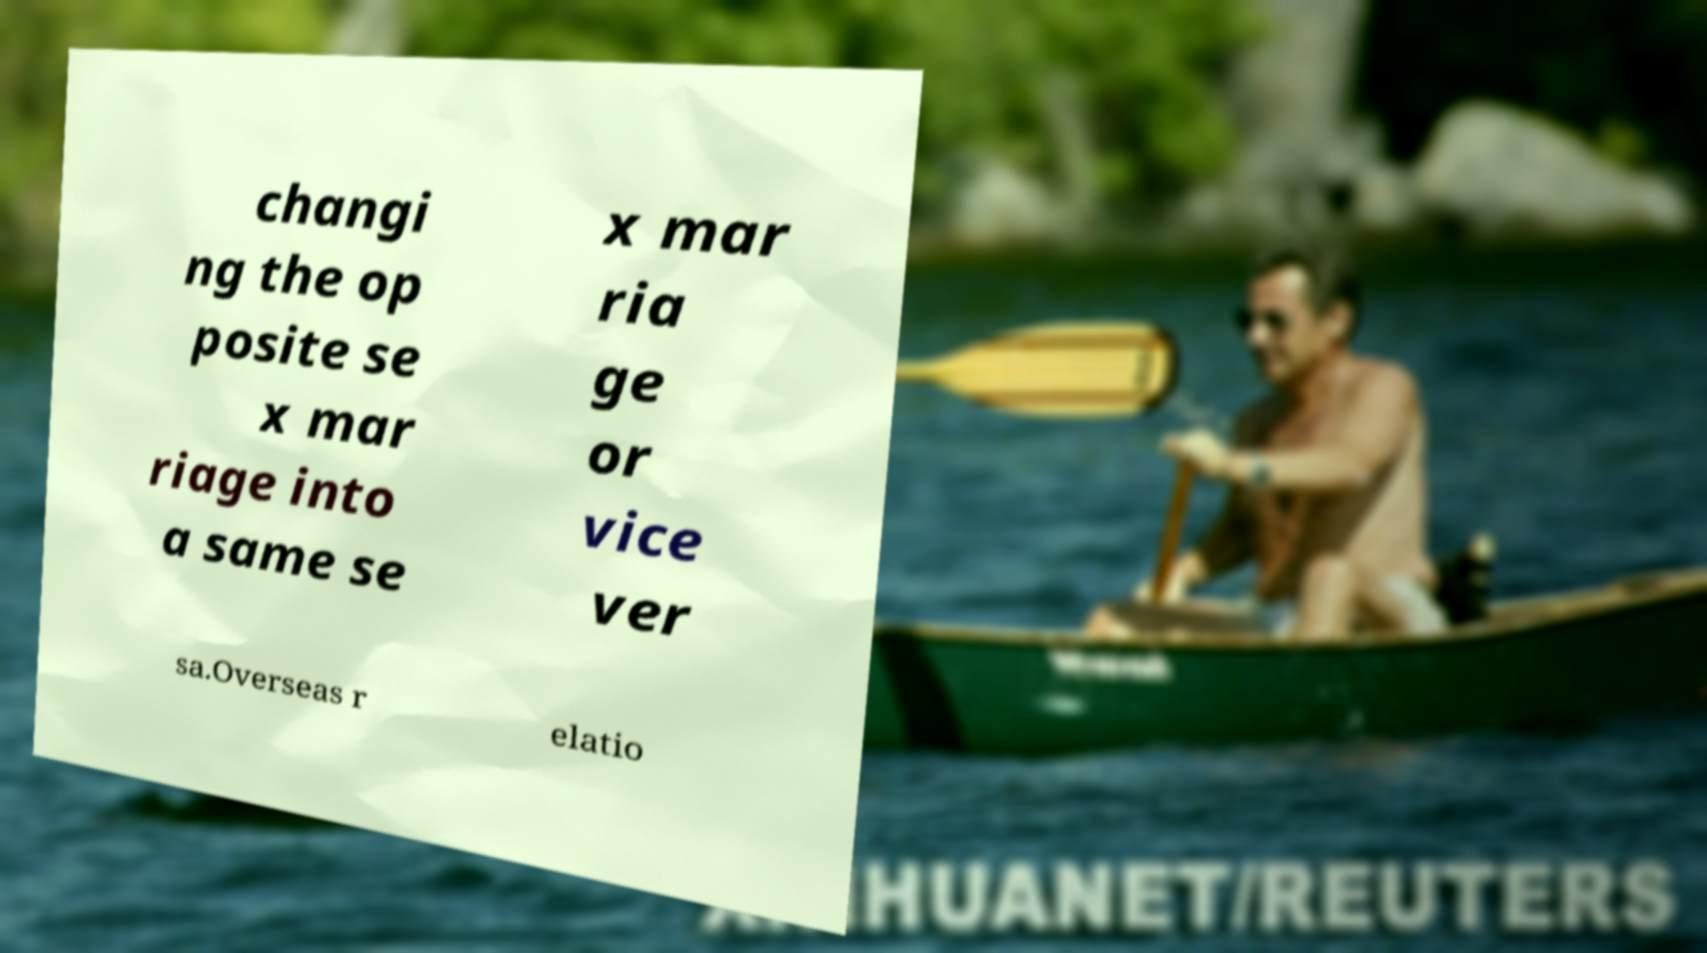Please read and relay the text visible in this image. What does it say? changi ng the op posite se x mar riage into a same se x mar ria ge or vice ver sa.Overseas r elatio 